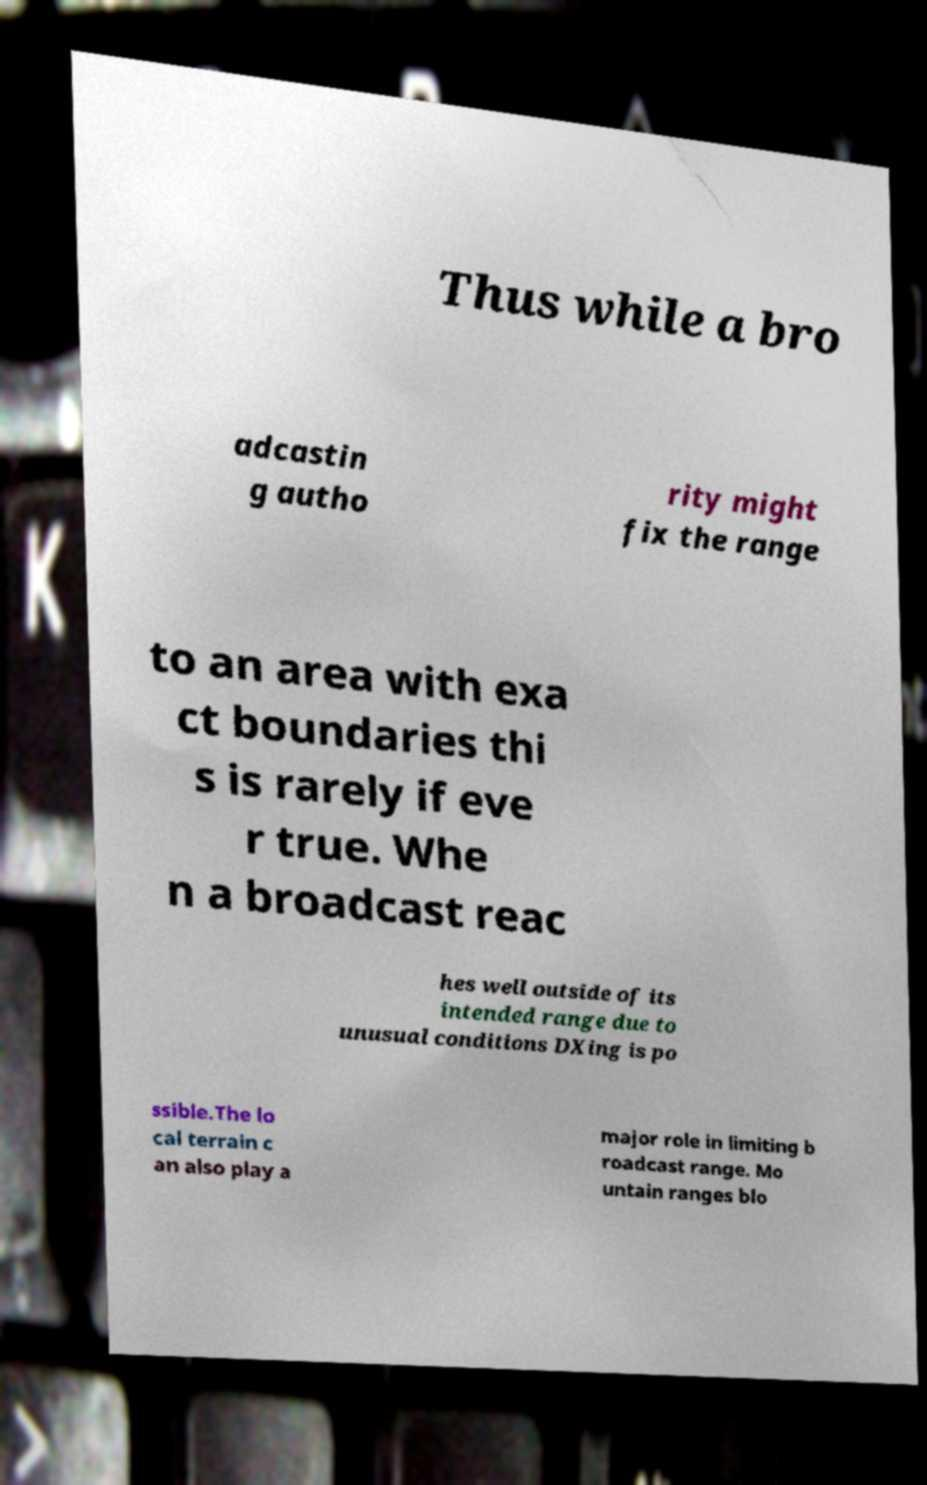Could you assist in decoding the text presented in this image and type it out clearly? Thus while a bro adcastin g autho rity might fix the range to an area with exa ct boundaries thi s is rarely if eve r true. Whe n a broadcast reac hes well outside of its intended range due to unusual conditions DXing is po ssible.The lo cal terrain c an also play a major role in limiting b roadcast range. Mo untain ranges blo 